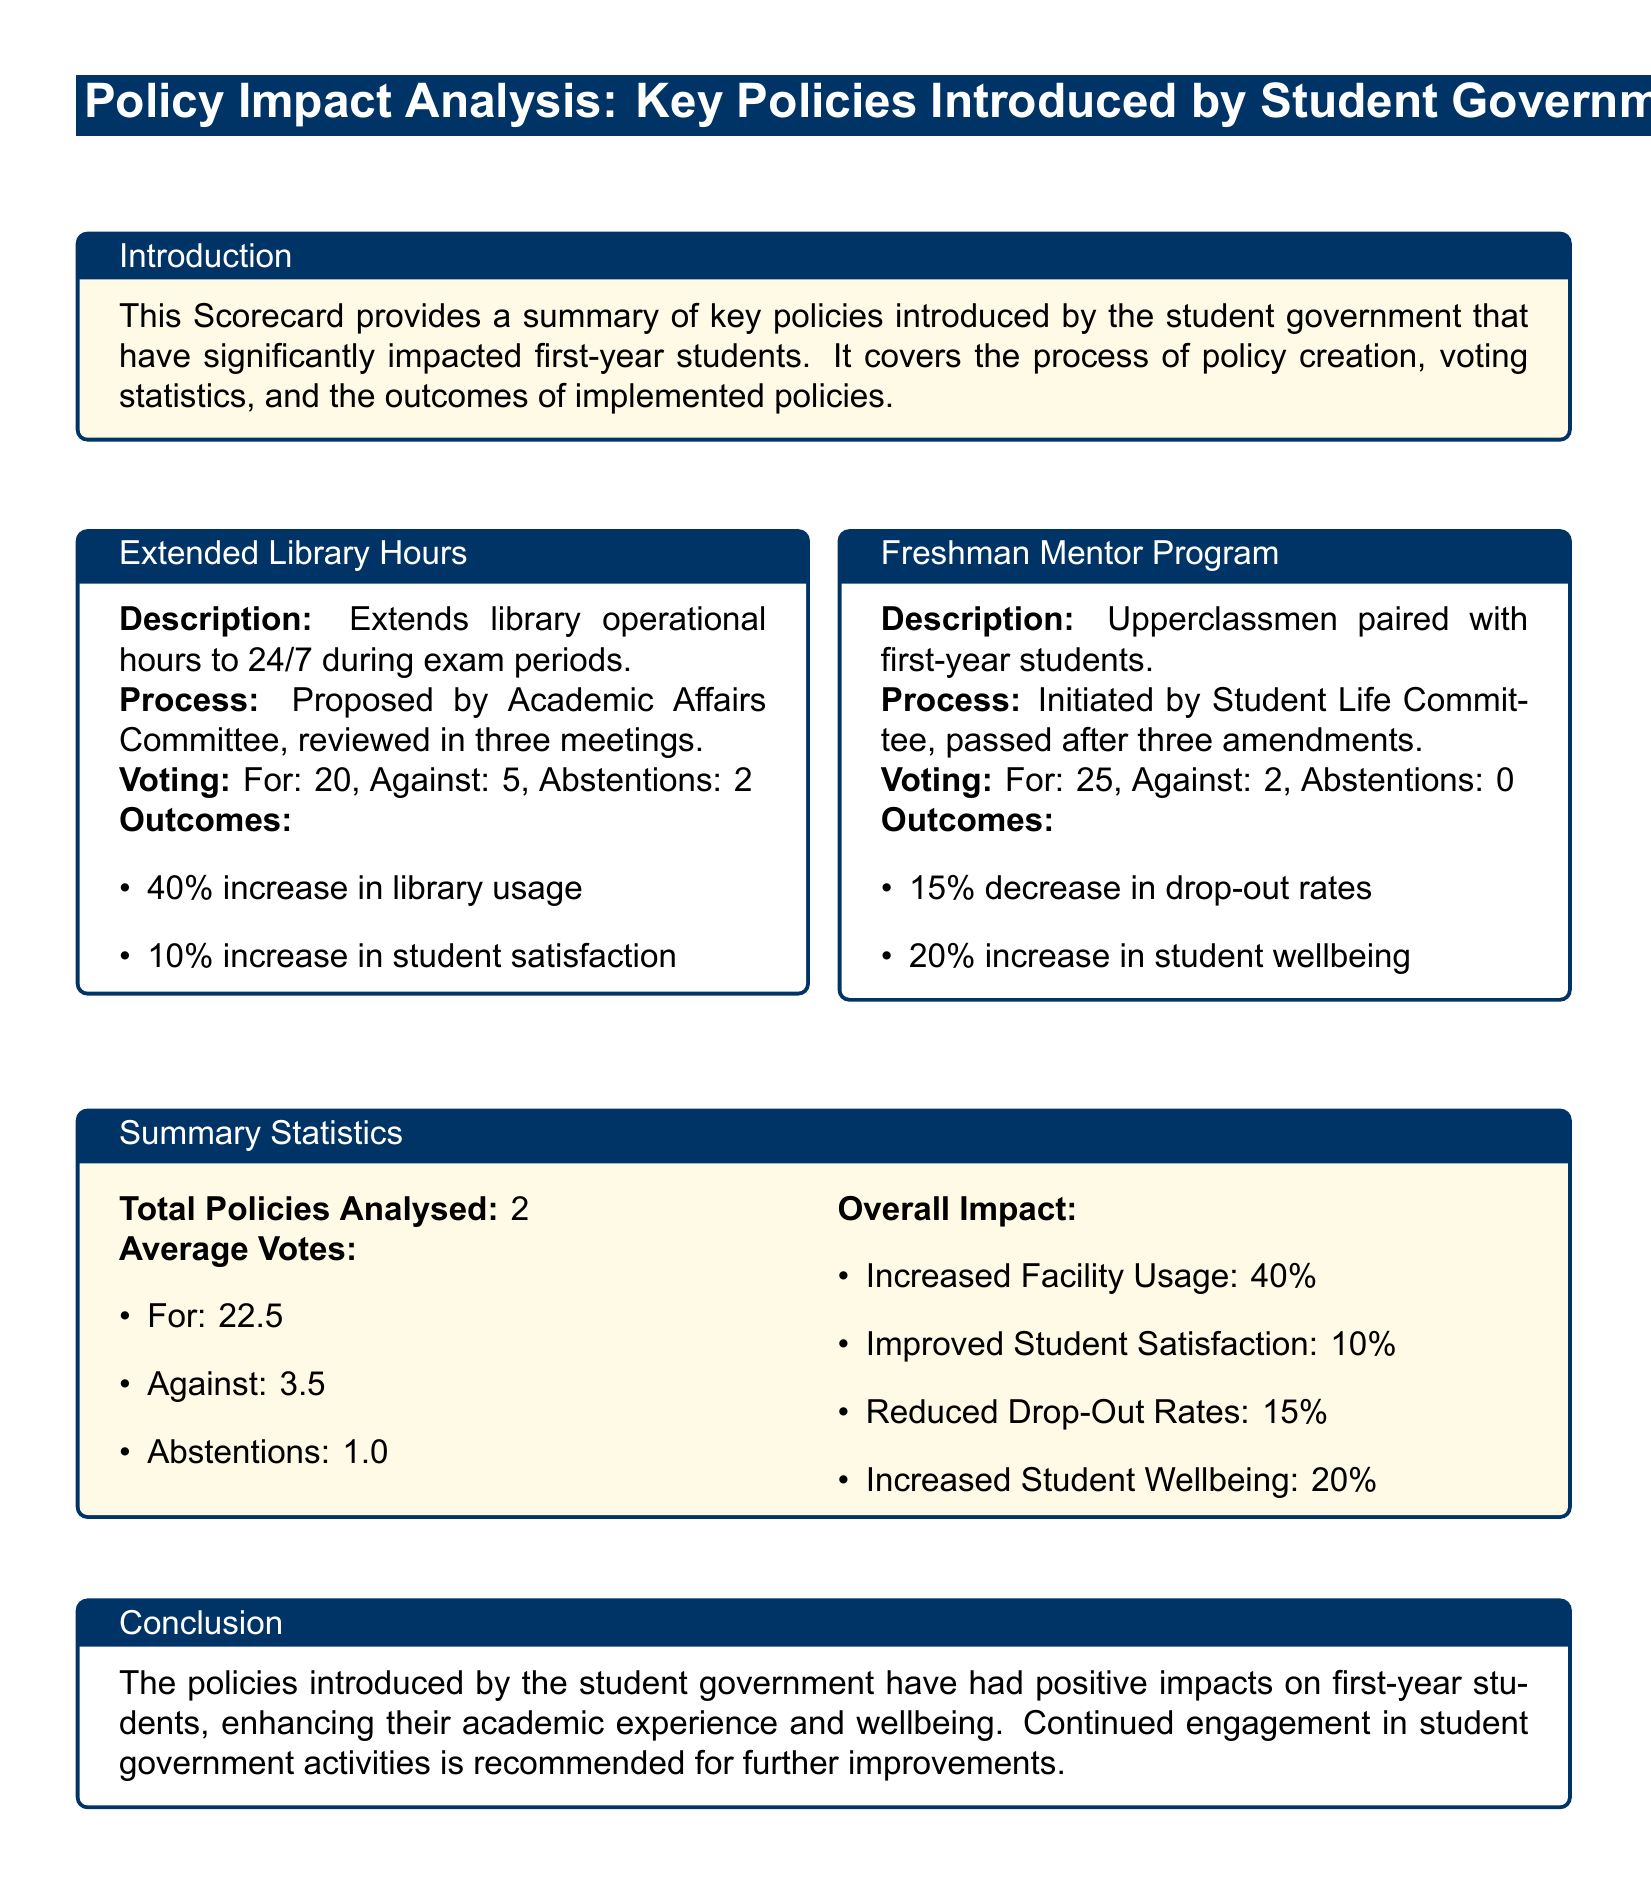What are the extended library hours during exam periods? The extended library hours are 24/7 during exam periods.
Answer: 24/7 Who proposed the Extended Library Hours policy? The Extended Library Hours policy was proposed by the Academic Affairs Committee.
Answer: Academic Affairs Committee What was the voting result for the Freshman Mentor Program? The voting result for the Freshman Mentor Program was 25 for, 2 against, and 0 abstentions.
Answer: For: 25, Against: 2, Abstentions: 0 What percentage increase in library usage was reported? The percentage increase in library usage reported was 40%.
Answer: 40% How many policies were analyzed in total? The total number of policies analyzed was 2.
Answer: 2 What was the average number of abstentions per policy? The average number of abstentions per policy was 1.0.
Answer: 1.0 What percentage decrease in drop-out rates was achieved? The percentage decrease in drop-out rates achieved was 15%.
Answer: 15% Which committee initiated the Freshman Mentor Program? The Freshman Mentor Program was initiated by the Student Life Committee.
Answer: Student Life Committee What was the percentage increase in student satisfaction? The percentage increase in student satisfaction was 10%.
Answer: 10% 